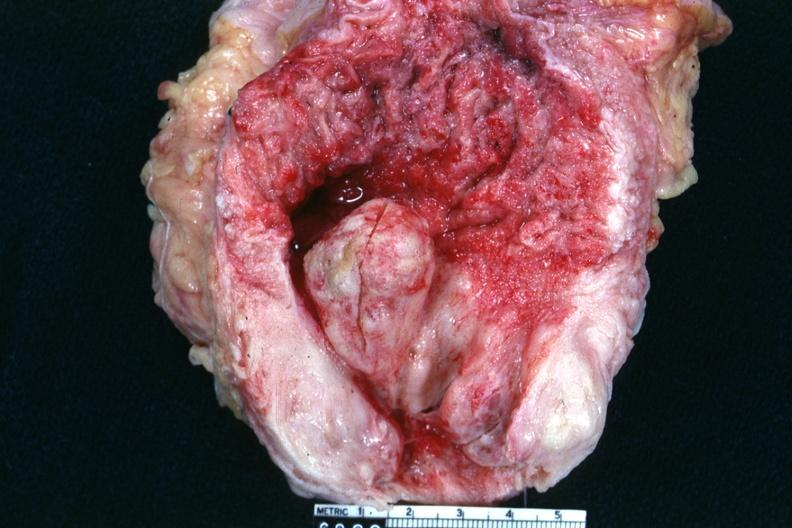what is present?
Answer the question using a single word or phrase. Hyperplasia 